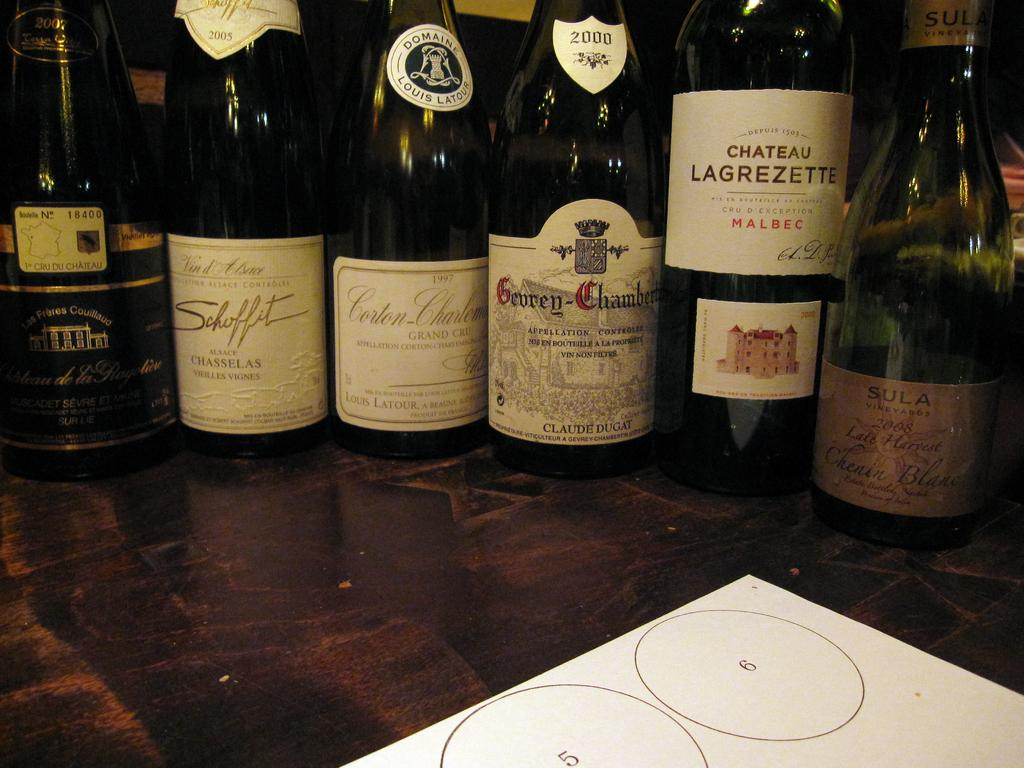<image>
Present a compact description of the photo's key features. Wine bottles placed next to one another with Chateau Lagrezette being the first. 